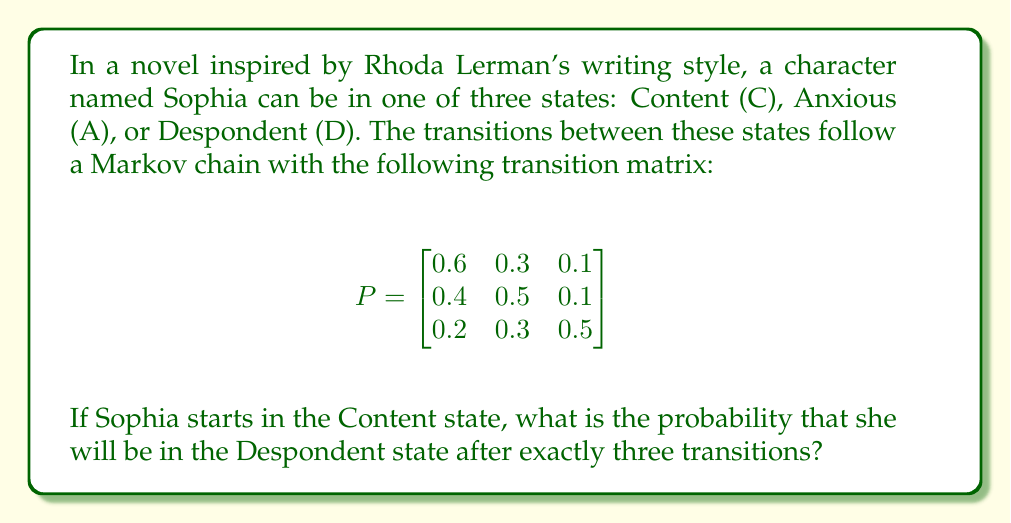Help me with this question. To solve this problem, we need to use the properties of Markov chains and matrix multiplication. Let's follow these steps:

1) The initial state vector for Sophia is $\pi_0 = [1, 0, 0]$, as she starts in the Content state.

2) We need to find $\pi_3 = \pi_0 P^3$, where $P^3$ is the transition matrix raised to the power of 3.

3) Let's calculate $P^2$ first:

   $$P^2 = P \times P = \begin{bmatrix}
   0.52 & 0.33 & 0.15 \\
   0.46 & 0.37 & 0.17 \\
   0.34 & 0.36 & 0.30
   \end{bmatrix}$$

4) Now, let's calculate $P^3$:

   $$P^3 = P^2 \times P = \begin{bmatrix}
   0.484 & 0.339 & 0.177 \\
   0.454 & 0.355 & 0.191 \\
   0.394 & 0.354 & 0.252
   \end{bmatrix}$$

5) Now, we can compute $\pi_3 = \pi_0 P^3$:

   $$\pi_3 = [1, 0, 0] \times \begin{bmatrix}
   0.484 & 0.339 & 0.177 \\
   0.454 & 0.355 & 0.191 \\
   0.394 & 0.354 & 0.252
   \end{bmatrix} = [0.484, 0.339, 0.177]$$

6) The probability of Sophia being in the Despondent state after three transitions is the third element of $\pi_3$, which is 0.177.
Answer: 0.177 